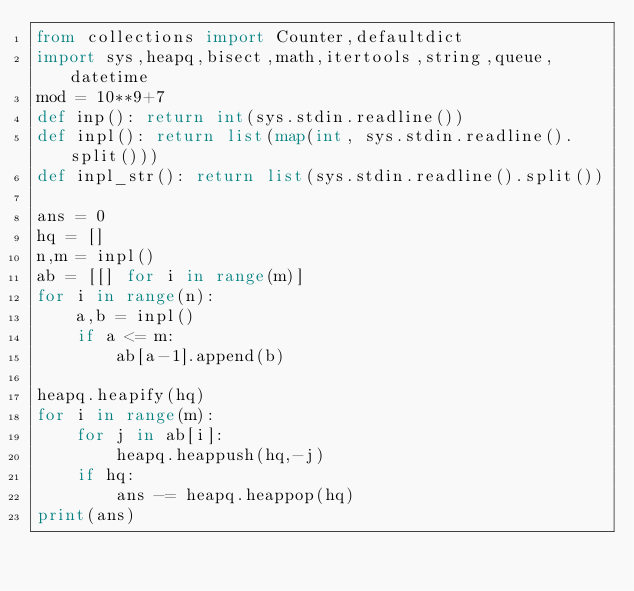Convert code to text. <code><loc_0><loc_0><loc_500><loc_500><_Python_>from collections import Counter,defaultdict
import sys,heapq,bisect,math,itertools,string,queue,datetime
mod = 10**9+7
def inp(): return int(sys.stdin.readline())
def inpl(): return list(map(int, sys.stdin.readline().split()))
def inpl_str(): return list(sys.stdin.readline().split())

ans = 0
hq = []
n,m = inpl()
ab = [[] for i in range(m)]
for i in range(n):
    a,b = inpl()
    if a <= m:
        ab[a-1].append(b)

heapq.heapify(hq)
for i in range(m):
    for j in ab[i]:
        heapq.heappush(hq,-j)
    if hq:
        ans -= heapq.heappop(hq)
print(ans)
</code> 